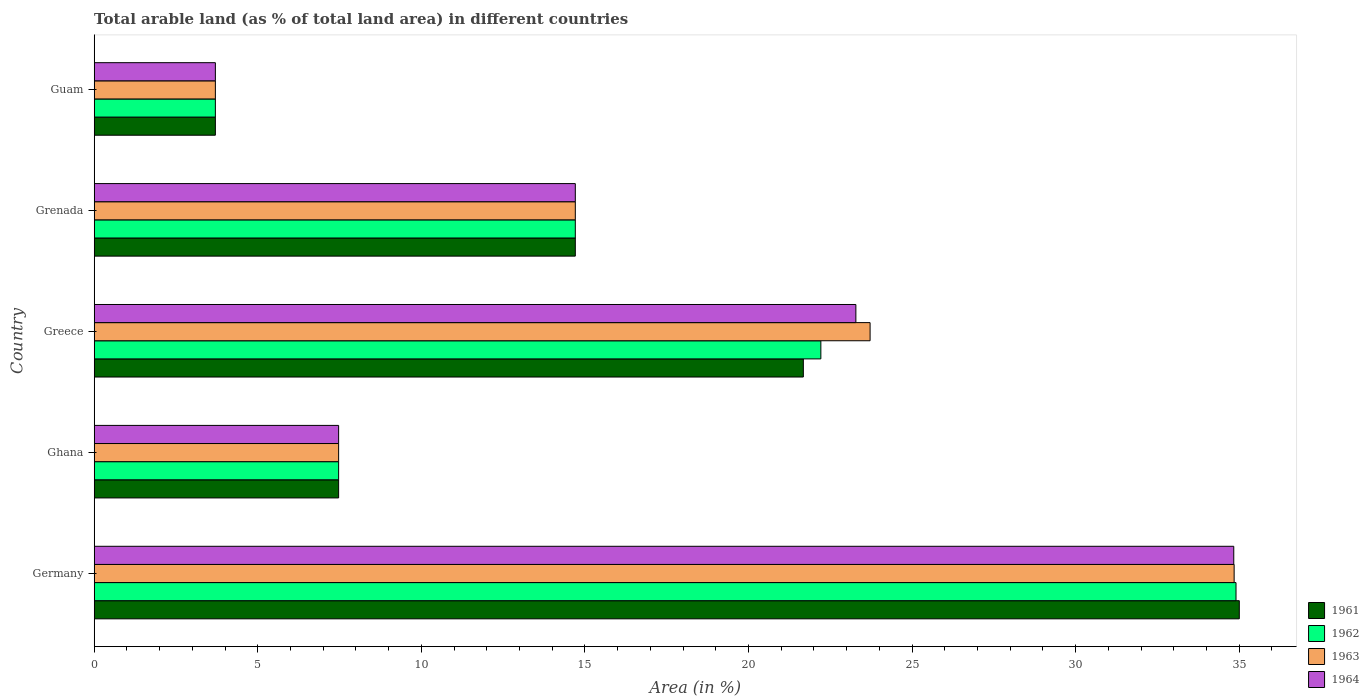How many groups of bars are there?
Offer a terse response. 5. How many bars are there on the 1st tick from the top?
Provide a succinct answer. 4. In how many cases, is the number of bars for a given country not equal to the number of legend labels?
Offer a terse response. 0. What is the percentage of arable land in 1961 in Ghana?
Provide a short and direct response. 7.47. Across all countries, what is the maximum percentage of arable land in 1963?
Provide a succinct answer. 34.84. Across all countries, what is the minimum percentage of arable land in 1964?
Your answer should be compact. 3.7. In which country was the percentage of arable land in 1964 minimum?
Provide a short and direct response. Guam. What is the total percentage of arable land in 1962 in the graph?
Ensure brevity in your answer.  82.99. What is the difference between the percentage of arable land in 1961 in Grenada and that in Guam?
Your response must be concise. 11. What is the difference between the percentage of arable land in 1963 in Ghana and the percentage of arable land in 1961 in Germany?
Give a very brief answer. -27.53. What is the average percentage of arable land in 1962 per country?
Your answer should be compact. 16.6. What is the difference between the percentage of arable land in 1962 and percentage of arable land in 1961 in Guam?
Keep it short and to the point. 0. In how many countries, is the percentage of arable land in 1961 greater than 31 %?
Make the answer very short. 1. What is the ratio of the percentage of arable land in 1962 in Germany to that in Greece?
Offer a terse response. 1.57. Is the difference between the percentage of arable land in 1962 in Ghana and Guam greater than the difference between the percentage of arable land in 1961 in Ghana and Guam?
Make the answer very short. No. What is the difference between the highest and the second highest percentage of arable land in 1964?
Ensure brevity in your answer.  11.55. What is the difference between the highest and the lowest percentage of arable land in 1961?
Offer a very short reply. 31.3. Is it the case that in every country, the sum of the percentage of arable land in 1961 and percentage of arable land in 1964 is greater than the sum of percentage of arable land in 1963 and percentage of arable land in 1962?
Give a very brief answer. No. What does the 1st bar from the top in Germany represents?
Your answer should be compact. 1964. What does the 4th bar from the bottom in Grenada represents?
Your answer should be very brief. 1964. Is it the case that in every country, the sum of the percentage of arable land in 1961 and percentage of arable land in 1962 is greater than the percentage of arable land in 1964?
Offer a terse response. Yes. Are all the bars in the graph horizontal?
Provide a succinct answer. Yes. Does the graph contain any zero values?
Make the answer very short. No. Does the graph contain grids?
Give a very brief answer. No. Where does the legend appear in the graph?
Provide a short and direct response. Bottom right. What is the title of the graph?
Make the answer very short. Total arable land (as % of total land area) in different countries. What is the label or title of the X-axis?
Keep it short and to the point. Area (in %). What is the Area (in %) of 1961 in Germany?
Provide a succinct answer. 35. What is the Area (in %) of 1962 in Germany?
Give a very brief answer. 34.9. What is the Area (in %) of 1963 in Germany?
Provide a short and direct response. 34.84. What is the Area (in %) in 1964 in Germany?
Provide a short and direct response. 34.83. What is the Area (in %) in 1961 in Ghana?
Provide a succinct answer. 7.47. What is the Area (in %) of 1962 in Ghana?
Make the answer very short. 7.47. What is the Area (in %) in 1963 in Ghana?
Your response must be concise. 7.47. What is the Area (in %) in 1964 in Ghana?
Offer a very short reply. 7.47. What is the Area (in %) in 1961 in Greece?
Keep it short and to the point. 21.68. What is the Area (in %) in 1962 in Greece?
Your answer should be very brief. 22.21. What is the Area (in %) in 1963 in Greece?
Give a very brief answer. 23.72. What is the Area (in %) in 1964 in Greece?
Offer a terse response. 23.28. What is the Area (in %) of 1961 in Grenada?
Your answer should be very brief. 14.71. What is the Area (in %) of 1962 in Grenada?
Your answer should be compact. 14.71. What is the Area (in %) in 1963 in Grenada?
Provide a succinct answer. 14.71. What is the Area (in %) of 1964 in Grenada?
Ensure brevity in your answer.  14.71. What is the Area (in %) of 1961 in Guam?
Your response must be concise. 3.7. What is the Area (in %) in 1962 in Guam?
Your answer should be compact. 3.7. What is the Area (in %) in 1963 in Guam?
Provide a short and direct response. 3.7. What is the Area (in %) in 1964 in Guam?
Provide a succinct answer. 3.7. Across all countries, what is the maximum Area (in %) in 1961?
Keep it short and to the point. 35. Across all countries, what is the maximum Area (in %) of 1962?
Your answer should be compact. 34.9. Across all countries, what is the maximum Area (in %) of 1963?
Your answer should be very brief. 34.84. Across all countries, what is the maximum Area (in %) in 1964?
Give a very brief answer. 34.83. Across all countries, what is the minimum Area (in %) in 1961?
Your answer should be very brief. 3.7. Across all countries, what is the minimum Area (in %) of 1962?
Offer a terse response. 3.7. Across all countries, what is the minimum Area (in %) of 1963?
Provide a short and direct response. 3.7. Across all countries, what is the minimum Area (in %) of 1964?
Provide a short and direct response. 3.7. What is the total Area (in %) in 1961 in the graph?
Offer a very short reply. 82.56. What is the total Area (in %) of 1962 in the graph?
Provide a short and direct response. 82.99. What is the total Area (in %) in 1963 in the graph?
Offer a very short reply. 84.44. What is the total Area (in %) of 1964 in the graph?
Ensure brevity in your answer.  83.99. What is the difference between the Area (in %) of 1961 in Germany and that in Ghana?
Provide a succinct answer. 27.53. What is the difference between the Area (in %) in 1962 in Germany and that in Ghana?
Make the answer very short. 27.43. What is the difference between the Area (in %) of 1963 in Germany and that in Ghana?
Offer a terse response. 27.37. What is the difference between the Area (in %) of 1964 in Germany and that in Ghana?
Provide a short and direct response. 27.36. What is the difference between the Area (in %) in 1961 in Germany and that in Greece?
Your response must be concise. 13.33. What is the difference between the Area (in %) in 1962 in Germany and that in Greece?
Ensure brevity in your answer.  12.69. What is the difference between the Area (in %) in 1963 in Germany and that in Greece?
Make the answer very short. 11.13. What is the difference between the Area (in %) of 1964 in Germany and that in Greece?
Offer a terse response. 11.55. What is the difference between the Area (in %) of 1961 in Germany and that in Grenada?
Provide a succinct answer. 20.3. What is the difference between the Area (in %) of 1962 in Germany and that in Grenada?
Ensure brevity in your answer.  20.2. What is the difference between the Area (in %) in 1963 in Germany and that in Grenada?
Offer a very short reply. 20.14. What is the difference between the Area (in %) in 1964 in Germany and that in Grenada?
Offer a terse response. 20.13. What is the difference between the Area (in %) of 1961 in Germany and that in Guam?
Ensure brevity in your answer.  31.3. What is the difference between the Area (in %) in 1962 in Germany and that in Guam?
Provide a short and direct response. 31.2. What is the difference between the Area (in %) of 1963 in Germany and that in Guam?
Provide a short and direct response. 31.14. What is the difference between the Area (in %) in 1964 in Germany and that in Guam?
Provide a succinct answer. 31.13. What is the difference between the Area (in %) of 1961 in Ghana and that in Greece?
Keep it short and to the point. -14.2. What is the difference between the Area (in %) of 1962 in Ghana and that in Greece?
Provide a succinct answer. -14.74. What is the difference between the Area (in %) in 1963 in Ghana and that in Greece?
Give a very brief answer. -16.24. What is the difference between the Area (in %) of 1964 in Ghana and that in Greece?
Your answer should be compact. -15.81. What is the difference between the Area (in %) in 1961 in Ghana and that in Grenada?
Offer a terse response. -7.23. What is the difference between the Area (in %) in 1962 in Ghana and that in Grenada?
Offer a terse response. -7.23. What is the difference between the Area (in %) in 1963 in Ghana and that in Grenada?
Provide a short and direct response. -7.23. What is the difference between the Area (in %) in 1964 in Ghana and that in Grenada?
Your answer should be compact. -7.23. What is the difference between the Area (in %) in 1961 in Ghana and that in Guam?
Your answer should be very brief. 3.77. What is the difference between the Area (in %) of 1962 in Ghana and that in Guam?
Make the answer very short. 3.77. What is the difference between the Area (in %) in 1963 in Ghana and that in Guam?
Offer a terse response. 3.77. What is the difference between the Area (in %) of 1964 in Ghana and that in Guam?
Provide a succinct answer. 3.77. What is the difference between the Area (in %) in 1961 in Greece and that in Grenada?
Your answer should be compact. 6.97. What is the difference between the Area (in %) of 1962 in Greece and that in Grenada?
Keep it short and to the point. 7.51. What is the difference between the Area (in %) in 1963 in Greece and that in Grenada?
Ensure brevity in your answer.  9.01. What is the difference between the Area (in %) in 1964 in Greece and that in Grenada?
Provide a succinct answer. 8.58. What is the difference between the Area (in %) of 1961 in Greece and that in Guam?
Your answer should be very brief. 17.97. What is the difference between the Area (in %) in 1962 in Greece and that in Guam?
Ensure brevity in your answer.  18.51. What is the difference between the Area (in %) of 1963 in Greece and that in Guam?
Keep it short and to the point. 20.01. What is the difference between the Area (in %) of 1964 in Greece and that in Guam?
Offer a terse response. 19.58. What is the difference between the Area (in %) of 1961 in Grenada and that in Guam?
Your answer should be very brief. 11. What is the difference between the Area (in %) of 1962 in Grenada and that in Guam?
Your answer should be compact. 11. What is the difference between the Area (in %) of 1963 in Grenada and that in Guam?
Give a very brief answer. 11. What is the difference between the Area (in %) of 1964 in Grenada and that in Guam?
Provide a succinct answer. 11. What is the difference between the Area (in %) of 1961 in Germany and the Area (in %) of 1962 in Ghana?
Give a very brief answer. 27.53. What is the difference between the Area (in %) in 1961 in Germany and the Area (in %) in 1963 in Ghana?
Your answer should be very brief. 27.53. What is the difference between the Area (in %) of 1961 in Germany and the Area (in %) of 1964 in Ghana?
Your response must be concise. 27.53. What is the difference between the Area (in %) of 1962 in Germany and the Area (in %) of 1963 in Ghana?
Provide a succinct answer. 27.43. What is the difference between the Area (in %) of 1962 in Germany and the Area (in %) of 1964 in Ghana?
Offer a terse response. 27.43. What is the difference between the Area (in %) in 1963 in Germany and the Area (in %) in 1964 in Ghana?
Make the answer very short. 27.37. What is the difference between the Area (in %) in 1961 in Germany and the Area (in %) in 1962 in Greece?
Offer a terse response. 12.79. What is the difference between the Area (in %) in 1961 in Germany and the Area (in %) in 1963 in Greece?
Provide a short and direct response. 11.29. What is the difference between the Area (in %) in 1961 in Germany and the Area (in %) in 1964 in Greece?
Make the answer very short. 11.72. What is the difference between the Area (in %) of 1962 in Germany and the Area (in %) of 1963 in Greece?
Your answer should be very brief. 11.19. What is the difference between the Area (in %) in 1962 in Germany and the Area (in %) in 1964 in Greece?
Your answer should be very brief. 11.62. What is the difference between the Area (in %) of 1963 in Germany and the Area (in %) of 1964 in Greece?
Offer a very short reply. 11.56. What is the difference between the Area (in %) of 1961 in Germany and the Area (in %) of 1962 in Grenada?
Your response must be concise. 20.3. What is the difference between the Area (in %) of 1961 in Germany and the Area (in %) of 1963 in Grenada?
Offer a very short reply. 20.3. What is the difference between the Area (in %) in 1961 in Germany and the Area (in %) in 1964 in Grenada?
Provide a succinct answer. 20.3. What is the difference between the Area (in %) in 1962 in Germany and the Area (in %) in 1963 in Grenada?
Offer a very short reply. 20.2. What is the difference between the Area (in %) in 1962 in Germany and the Area (in %) in 1964 in Grenada?
Ensure brevity in your answer.  20.2. What is the difference between the Area (in %) in 1963 in Germany and the Area (in %) in 1964 in Grenada?
Your answer should be very brief. 20.14. What is the difference between the Area (in %) in 1961 in Germany and the Area (in %) in 1962 in Guam?
Give a very brief answer. 31.3. What is the difference between the Area (in %) in 1961 in Germany and the Area (in %) in 1963 in Guam?
Keep it short and to the point. 31.3. What is the difference between the Area (in %) of 1961 in Germany and the Area (in %) of 1964 in Guam?
Keep it short and to the point. 31.3. What is the difference between the Area (in %) of 1962 in Germany and the Area (in %) of 1963 in Guam?
Your answer should be very brief. 31.2. What is the difference between the Area (in %) in 1962 in Germany and the Area (in %) in 1964 in Guam?
Provide a short and direct response. 31.2. What is the difference between the Area (in %) of 1963 in Germany and the Area (in %) of 1964 in Guam?
Provide a succinct answer. 31.14. What is the difference between the Area (in %) of 1961 in Ghana and the Area (in %) of 1962 in Greece?
Ensure brevity in your answer.  -14.74. What is the difference between the Area (in %) in 1961 in Ghana and the Area (in %) in 1963 in Greece?
Give a very brief answer. -16.24. What is the difference between the Area (in %) of 1961 in Ghana and the Area (in %) of 1964 in Greece?
Your answer should be very brief. -15.81. What is the difference between the Area (in %) of 1962 in Ghana and the Area (in %) of 1963 in Greece?
Make the answer very short. -16.24. What is the difference between the Area (in %) in 1962 in Ghana and the Area (in %) in 1964 in Greece?
Your answer should be very brief. -15.81. What is the difference between the Area (in %) of 1963 in Ghana and the Area (in %) of 1964 in Greece?
Offer a terse response. -15.81. What is the difference between the Area (in %) in 1961 in Ghana and the Area (in %) in 1962 in Grenada?
Your answer should be very brief. -7.23. What is the difference between the Area (in %) of 1961 in Ghana and the Area (in %) of 1963 in Grenada?
Provide a succinct answer. -7.23. What is the difference between the Area (in %) in 1961 in Ghana and the Area (in %) in 1964 in Grenada?
Offer a very short reply. -7.23. What is the difference between the Area (in %) of 1962 in Ghana and the Area (in %) of 1963 in Grenada?
Keep it short and to the point. -7.23. What is the difference between the Area (in %) in 1962 in Ghana and the Area (in %) in 1964 in Grenada?
Your answer should be compact. -7.23. What is the difference between the Area (in %) of 1963 in Ghana and the Area (in %) of 1964 in Grenada?
Your answer should be very brief. -7.23. What is the difference between the Area (in %) of 1961 in Ghana and the Area (in %) of 1962 in Guam?
Your answer should be compact. 3.77. What is the difference between the Area (in %) in 1961 in Ghana and the Area (in %) in 1963 in Guam?
Ensure brevity in your answer.  3.77. What is the difference between the Area (in %) of 1961 in Ghana and the Area (in %) of 1964 in Guam?
Provide a succinct answer. 3.77. What is the difference between the Area (in %) in 1962 in Ghana and the Area (in %) in 1963 in Guam?
Your answer should be very brief. 3.77. What is the difference between the Area (in %) of 1962 in Ghana and the Area (in %) of 1964 in Guam?
Provide a short and direct response. 3.77. What is the difference between the Area (in %) of 1963 in Ghana and the Area (in %) of 1964 in Guam?
Offer a terse response. 3.77. What is the difference between the Area (in %) of 1961 in Greece and the Area (in %) of 1962 in Grenada?
Provide a succinct answer. 6.97. What is the difference between the Area (in %) in 1961 in Greece and the Area (in %) in 1963 in Grenada?
Your response must be concise. 6.97. What is the difference between the Area (in %) of 1961 in Greece and the Area (in %) of 1964 in Grenada?
Your answer should be very brief. 6.97. What is the difference between the Area (in %) in 1962 in Greece and the Area (in %) in 1963 in Grenada?
Offer a very short reply. 7.51. What is the difference between the Area (in %) in 1962 in Greece and the Area (in %) in 1964 in Grenada?
Offer a very short reply. 7.51. What is the difference between the Area (in %) of 1963 in Greece and the Area (in %) of 1964 in Grenada?
Make the answer very short. 9.01. What is the difference between the Area (in %) of 1961 in Greece and the Area (in %) of 1962 in Guam?
Ensure brevity in your answer.  17.97. What is the difference between the Area (in %) of 1961 in Greece and the Area (in %) of 1963 in Guam?
Offer a very short reply. 17.97. What is the difference between the Area (in %) in 1961 in Greece and the Area (in %) in 1964 in Guam?
Your answer should be very brief. 17.97. What is the difference between the Area (in %) in 1962 in Greece and the Area (in %) in 1963 in Guam?
Your response must be concise. 18.51. What is the difference between the Area (in %) of 1962 in Greece and the Area (in %) of 1964 in Guam?
Ensure brevity in your answer.  18.51. What is the difference between the Area (in %) in 1963 in Greece and the Area (in %) in 1964 in Guam?
Your answer should be very brief. 20.01. What is the difference between the Area (in %) in 1961 in Grenada and the Area (in %) in 1962 in Guam?
Your response must be concise. 11. What is the difference between the Area (in %) of 1961 in Grenada and the Area (in %) of 1963 in Guam?
Provide a succinct answer. 11. What is the difference between the Area (in %) in 1961 in Grenada and the Area (in %) in 1964 in Guam?
Provide a short and direct response. 11. What is the difference between the Area (in %) in 1962 in Grenada and the Area (in %) in 1963 in Guam?
Keep it short and to the point. 11. What is the difference between the Area (in %) in 1962 in Grenada and the Area (in %) in 1964 in Guam?
Ensure brevity in your answer.  11. What is the difference between the Area (in %) in 1963 in Grenada and the Area (in %) in 1964 in Guam?
Keep it short and to the point. 11. What is the average Area (in %) of 1961 per country?
Your answer should be compact. 16.51. What is the average Area (in %) of 1962 per country?
Provide a short and direct response. 16.6. What is the average Area (in %) of 1963 per country?
Your answer should be compact. 16.89. What is the average Area (in %) of 1964 per country?
Make the answer very short. 16.8. What is the difference between the Area (in %) of 1961 and Area (in %) of 1962 in Germany?
Provide a short and direct response. 0.1. What is the difference between the Area (in %) of 1961 and Area (in %) of 1963 in Germany?
Your answer should be very brief. 0.16. What is the difference between the Area (in %) of 1961 and Area (in %) of 1964 in Germany?
Provide a succinct answer. 0.17. What is the difference between the Area (in %) of 1962 and Area (in %) of 1963 in Germany?
Make the answer very short. 0.06. What is the difference between the Area (in %) of 1962 and Area (in %) of 1964 in Germany?
Ensure brevity in your answer.  0.07. What is the difference between the Area (in %) in 1963 and Area (in %) in 1964 in Germany?
Provide a succinct answer. 0.01. What is the difference between the Area (in %) of 1961 and Area (in %) of 1962 in Ghana?
Offer a terse response. 0. What is the difference between the Area (in %) of 1961 and Area (in %) of 1963 in Ghana?
Your answer should be very brief. 0. What is the difference between the Area (in %) of 1962 and Area (in %) of 1964 in Ghana?
Your answer should be compact. 0. What is the difference between the Area (in %) of 1961 and Area (in %) of 1962 in Greece?
Your response must be concise. -0.54. What is the difference between the Area (in %) in 1961 and Area (in %) in 1963 in Greece?
Provide a short and direct response. -2.04. What is the difference between the Area (in %) of 1961 and Area (in %) of 1964 in Greece?
Give a very brief answer. -1.61. What is the difference between the Area (in %) of 1962 and Area (in %) of 1963 in Greece?
Provide a short and direct response. -1.5. What is the difference between the Area (in %) of 1962 and Area (in %) of 1964 in Greece?
Keep it short and to the point. -1.07. What is the difference between the Area (in %) of 1963 and Area (in %) of 1964 in Greece?
Provide a succinct answer. 0.43. What is the difference between the Area (in %) in 1961 and Area (in %) in 1964 in Grenada?
Ensure brevity in your answer.  0. What is the difference between the Area (in %) in 1962 and Area (in %) in 1963 in Grenada?
Ensure brevity in your answer.  0. What is the difference between the Area (in %) of 1961 and Area (in %) of 1963 in Guam?
Offer a very short reply. 0. What is the difference between the Area (in %) in 1962 and Area (in %) in 1964 in Guam?
Offer a very short reply. 0. What is the difference between the Area (in %) of 1963 and Area (in %) of 1964 in Guam?
Provide a short and direct response. 0. What is the ratio of the Area (in %) of 1961 in Germany to that in Ghana?
Give a very brief answer. 4.68. What is the ratio of the Area (in %) of 1962 in Germany to that in Ghana?
Keep it short and to the point. 4.67. What is the ratio of the Area (in %) of 1963 in Germany to that in Ghana?
Give a very brief answer. 4.66. What is the ratio of the Area (in %) in 1964 in Germany to that in Ghana?
Offer a very short reply. 4.66. What is the ratio of the Area (in %) of 1961 in Germany to that in Greece?
Your response must be concise. 1.61. What is the ratio of the Area (in %) of 1962 in Germany to that in Greece?
Ensure brevity in your answer.  1.57. What is the ratio of the Area (in %) in 1963 in Germany to that in Greece?
Your answer should be compact. 1.47. What is the ratio of the Area (in %) of 1964 in Germany to that in Greece?
Your response must be concise. 1.5. What is the ratio of the Area (in %) in 1961 in Germany to that in Grenada?
Provide a short and direct response. 2.38. What is the ratio of the Area (in %) of 1962 in Germany to that in Grenada?
Give a very brief answer. 2.37. What is the ratio of the Area (in %) in 1963 in Germany to that in Grenada?
Your answer should be very brief. 2.37. What is the ratio of the Area (in %) of 1964 in Germany to that in Grenada?
Keep it short and to the point. 2.37. What is the ratio of the Area (in %) of 1961 in Germany to that in Guam?
Offer a terse response. 9.45. What is the ratio of the Area (in %) of 1962 in Germany to that in Guam?
Provide a short and direct response. 9.42. What is the ratio of the Area (in %) of 1963 in Germany to that in Guam?
Offer a terse response. 9.41. What is the ratio of the Area (in %) of 1964 in Germany to that in Guam?
Keep it short and to the point. 9.4. What is the ratio of the Area (in %) in 1961 in Ghana to that in Greece?
Your answer should be very brief. 0.34. What is the ratio of the Area (in %) in 1962 in Ghana to that in Greece?
Give a very brief answer. 0.34. What is the ratio of the Area (in %) in 1963 in Ghana to that in Greece?
Ensure brevity in your answer.  0.32. What is the ratio of the Area (in %) in 1964 in Ghana to that in Greece?
Your response must be concise. 0.32. What is the ratio of the Area (in %) in 1961 in Ghana to that in Grenada?
Make the answer very short. 0.51. What is the ratio of the Area (in %) of 1962 in Ghana to that in Grenada?
Your answer should be very brief. 0.51. What is the ratio of the Area (in %) of 1963 in Ghana to that in Grenada?
Keep it short and to the point. 0.51. What is the ratio of the Area (in %) of 1964 in Ghana to that in Grenada?
Make the answer very short. 0.51. What is the ratio of the Area (in %) of 1961 in Ghana to that in Guam?
Make the answer very short. 2.02. What is the ratio of the Area (in %) of 1962 in Ghana to that in Guam?
Offer a very short reply. 2.02. What is the ratio of the Area (in %) in 1963 in Ghana to that in Guam?
Offer a very short reply. 2.02. What is the ratio of the Area (in %) in 1964 in Ghana to that in Guam?
Offer a terse response. 2.02. What is the ratio of the Area (in %) in 1961 in Greece to that in Grenada?
Your answer should be very brief. 1.47. What is the ratio of the Area (in %) in 1962 in Greece to that in Grenada?
Provide a short and direct response. 1.51. What is the ratio of the Area (in %) in 1963 in Greece to that in Grenada?
Your response must be concise. 1.61. What is the ratio of the Area (in %) in 1964 in Greece to that in Grenada?
Provide a succinct answer. 1.58. What is the ratio of the Area (in %) in 1961 in Greece to that in Guam?
Ensure brevity in your answer.  5.85. What is the ratio of the Area (in %) in 1962 in Greece to that in Guam?
Your response must be concise. 6. What is the ratio of the Area (in %) of 1963 in Greece to that in Guam?
Keep it short and to the point. 6.4. What is the ratio of the Area (in %) of 1964 in Greece to that in Guam?
Ensure brevity in your answer.  6.29. What is the ratio of the Area (in %) in 1961 in Grenada to that in Guam?
Your answer should be very brief. 3.97. What is the ratio of the Area (in %) of 1962 in Grenada to that in Guam?
Offer a terse response. 3.97. What is the ratio of the Area (in %) of 1963 in Grenada to that in Guam?
Your answer should be very brief. 3.97. What is the ratio of the Area (in %) in 1964 in Grenada to that in Guam?
Provide a succinct answer. 3.97. What is the difference between the highest and the second highest Area (in %) in 1961?
Provide a succinct answer. 13.33. What is the difference between the highest and the second highest Area (in %) in 1962?
Offer a terse response. 12.69. What is the difference between the highest and the second highest Area (in %) in 1963?
Your answer should be compact. 11.13. What is the difference between the highest and the second highest Area (in %) in 1964?
Your answer should be compact. 11.55. What is the difference between the highest and the lowest Area (in %) in 1961?
Provide a succinct answer. 31.3. What is the difference between the highest and the lowest Area (in %) in 1962?
Give a very brief answer. 31.2. What is the difference between the highest and the lowest Area (in %) of 1963?
Make the answer very short. 31.14. What is the difference between the highest and the lowest Area (in %) of 1964?
Offer a very short reply. 31.13. 